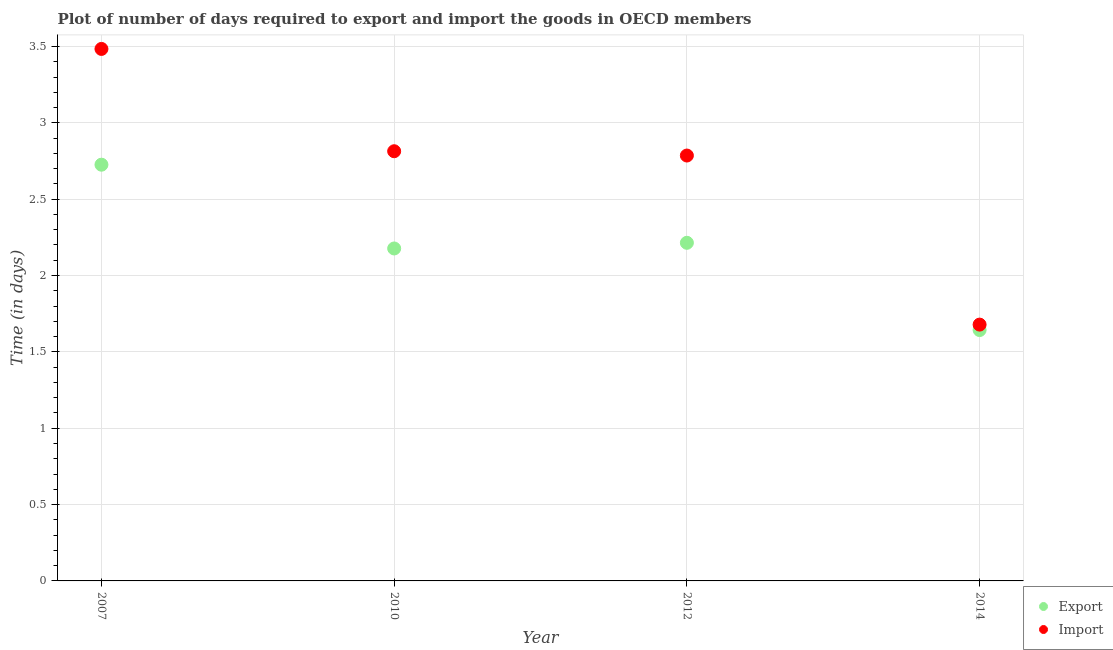How many different coloured dotlines are there?
Provide a short and direct response. 2. What is the time required to import in 2012?
Your answer should be compact. 2.79. Across all years, what is the maximum time required to import?
Offer a terse response. 3.48. Across all years, what is the minimum time required to import?
Offer a very short reply. 1.68. What is the total time required to import in the graph?
Offer a very short reply. 10.76. What is the difference between the time required to export in 2010 and that in 2012?
Make the answer very short. -0.04. What is the difference between the time required to export in 2014 and the time required to import in 2012?
Your answer should be very brief. -1.14. What is the average time required to import per year?
Offer a terse response. 2.69. In the year 2014, what is the difference between the time required to export and time required to import?
Provide a short and direct response. -0.04. In how many years, is the time required to import greater than 2.1 days?
Offer a very short reply. 3. What is the ratio of the time required to import in 2007 to that in 2010?
Offer a very short reply. 1.24. Is the time required to import in 2007 less than that in 2012?
Provide a succinct answer. No. What is the difference between the highest and the second highest time required to import?
Provide a succinct answer. 0.67. What is the difference between the highest and the lowest time required to export?
Offer a terse response. 1.08. Is the sum of the time required to import in 2007 and 2012 greater than the maximum time required to export across all years?
Make the answer very short. Yes. Does the time required to import monotonically increase over the years?
Your response must be concise. No. Is the time required to export strictly greater than the time required to import over the years?
Your answer should be compact. No. Is the time required to export strictly less than the time required to import over the years?
Give a very brief answer. Yes. How many dotlines are there?
Make the answer very short. 2. What is the title of the graph?
Make the answer very short. Plot of number of days required to export and import the goods in OECD members. What is the label or title of the X-axis?
Keep it short and to the point. Year. What is the label or title of the Y-axis?
Offer a terse response. Time (in days). What is the Time (in days) of Export in 2007?
Your response must be concise. 2.73. What is the Time (in days) of Import in 2007?
Your answer should be very brief. 3.48. What is the Time (in days) in Export in 2010?
Provide a short and direct response. 2.18. What is the Time (in days) in Import in 2010?
Offer a terse response. 2.81. What is the Time (in days) in Export in 2012?
Your response must be concise. 2.21. What is the Time (in days) of Import in 2012?
Offer a terse response. 2.79. What is the Time (in days) in Export in 2014?
Give a very brief answer. 1.64. What is the Time (in days) in Import in 2014?
Your answer should be compact. 1.68. Across all years, what is the maximum Time (in days) of Export?
Provide a short and direct response. 2.73. Across all years, what is the maximum Time (in days) in Import?
Make the answer very short. 3.48. Across all years, what is the minimum Time (in days) of Export?
Ensure brevity in your answer.  1.64. Across all years, what is the minimum Time (in days) in Import?
Ensure brevity in your answer.  1.68. What is the total Time (in days) of Export in the graph?
Keep it short and to the point. 8.76. What is the total Time (in days) of Import in the graph?
Ensure brevity in your answer.  10.76. What is the difference between the Time (in days) in Export in 2007 and that in 2010?
Make the answer very short. 0.55. What is the difference between the Time (in days) in Import in 2007 and that in 2010?
Offer a very short reply. 0.67. What is the difference between the Time (in days) in Export in 2007 and that in 2012?
Provide a short and direct response. 0.51. What is the difference between the Time (in days) in Import in 2007 and that in 2012?
Keep it short and to the point. 0.7. What is the difference between the Time (in days) in Export in 2007 and that in 2014?
Offer a terse response. 1.08. What is the difference between the Time (in days) of Import in 2007 and that in 2014?
Your answer should be very brief. 1.81. What is the difference between the Time (in days) in Export in 2010 and that in 2012?
Your answer should be very brief. -0.04. What is the difference between the Time (in days) of Import in 2010 and that in 2012?
Keep it short and to the point. 0.03. What is the difference between the Time (in days) of Export in 2010 and that in 2014?
Give a very brief answer. 0.53. What is the difference between the Time (in days) of Import in 2010 and that in 2014?
Keep it short and to the point. 1.14. What is the difference between the Time (in days) in Export in 2012 and that in 2014?
Your response must be concise. 0.57. What is the difference between the Time (in days) of Import in 2012 and that in 2014?
Provide a succinct answer. 1.11. What is the difference between the Time (in days) in Export in 2007 and the Time (in days) in Import in 2010?
Give a very brief answer. -0.09. What is the difference between the Time (in days) of Export in 2007 and the Time (in days) of Import in 2012?
Your answer should be compact. -0.06. What is the difference between the Time (in days) in Export in 2007 and the Time (in days) in Import in 2014?
Your answer should be very brief. 1.05. What is the difference between the Time (in days) of Export in 2010 and the Time (in days) of Import in 2012?
Ensure brevity in your answer.  -0.61. What is the difference between the Time (in days) of Export in 2010 and the Time (in days) of Import in 2014?
Give a very brief answer. 0.5. What is the difference between the Time (in days) in Export in 2012 and the Time (in days) in Import in 2014?
Ensure brevity in your answer.  0.54. What is the average Time (in days) in Export per year?
Your response must be concise. 2.19. What is the average Time (in days) of Import per year?
Your answer should be compact. 2.69. In the year 2007, what is the difference between the Time (in days) of Export and Time (in days) of Import?
Offer a very short reply. -0.76. In the year 2010, what is the difference between the Time (in days) in Export and Time (in days) in Import?
Your answer should be very brief. -0.64. In the year 2012, what is the difference between the Time (in days) in Export and Time (in days) in Import?
Your response must be concise. -0.57. In the year 2014, what is the difference between the Time (in days) in Export and Time (in days) in Import?
Offer a very short reply. -0.04. What is the ratio of the Time (in days) in Export in 2007 to that in 2010?
Ensure brevity in your answer.  1.25. What is the ratio of the Time (in days) of Import in 2007 to that in 2010?
Offer a terse response. 1.24. What is the ratio of the Time (in days) in Export in 2007 to that in 2012?
Give a very brief answer. 1.23. What is the ratio of the Time (in days) in Import in 2007 to that in 2012?
Give a very brief answer. 1.25. What is the ratio of the Time (in days) of Export in 2007 to that in 2014?
Make the answer very short. 1.66. What is the ratio of the Time (in days) of Import in 2007 to that in 2014?
Make the answer very short. 2.08. What is the ratio of the Time (in days) in Export in 2010 to that in 2012?
Your answer should be compact. 0.98. What is the ratio of the Time (in days) of Import in 2010 to that in 2012?
Your response must be concise. 1.01. What is the ratio of the Time (in days) in Export in 2010 to that in 2014?
Make the answer very short. 1.33. What is the ratio of the Time (in days) in Import in 2010 to that in 2014?
Your response must be concise. 1.68. What is the ratio of the Time (in days) in Export in 2012 to that in 2014?
Ensure brevity in your answer.  1.35. What is the ratio of the Time (in days) in Import in 2012 to that in 2014?
Offer a terse response. 1.66. What is the difference between the highest and the second highest Time (in days) in Export?
Offer a very short reply. 0.51. What is the difference between the highest and the second highest Time (in days) of Import?
Provide a succinct answer. 0.67. What is the difference between the highest and the lowest Time (in days) of Export?
Provide a short and direct response. 1.08. What is the difference between the highest and the lowest Time (in days) of Import?
Your answer should be very brief. 1.81. 